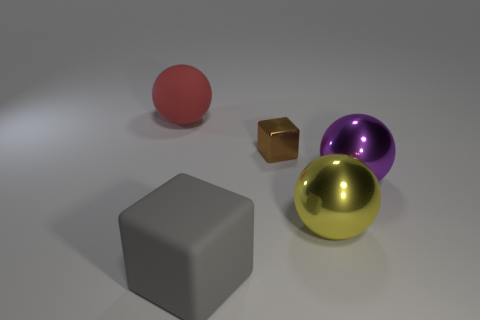How many shiny objects are big things or brown blocks?
Offer a very short reply. 3. What is the size of the rubber object that is in front of the brown block?
Ensure brevity in your answer.  Large. What is the size of the sphere that is made of the same material as the big gray object?
Give a very brief answer. Large. Are any large gray rubber things visible?
Your answer should be very brief. Yes. Does the large red matte thing have the same shape as the big yellow thing that is right of the big gray block?
Provide a short and direct response. Yes. There is a big matte object that is right of the thing left of the large rubber thing on the right side of the matte sphere; what color is it?
Your answer should be compact. Gray. Are there any large red rubber things in front of the brown shiny cube?
Keep it short and to the point. No. Are there any other things that have the same material as the brown thing?
Give a very brief answer. Yes. The big rubber block has what color?
Provide a short and direct response. Gray. There is a brown metallic thing behind the big purple ball; does it have the same shape as the gray rubber object?
Offer a very short reply. Yes. 